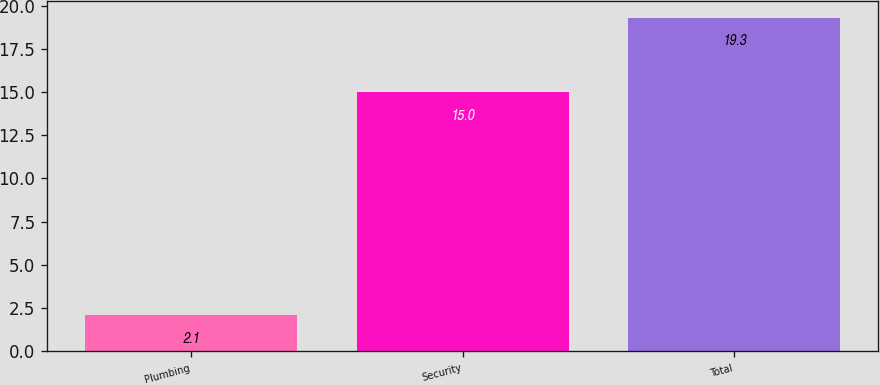Convert chart. <chart><loc_0><loc_0><loc_500><loc_500><bar_chart><fcel>Plumbing<fcel>Security<fcel>Total<nl><fcel>2.1<fcel>15<fcel>19.3<nl></chart> 